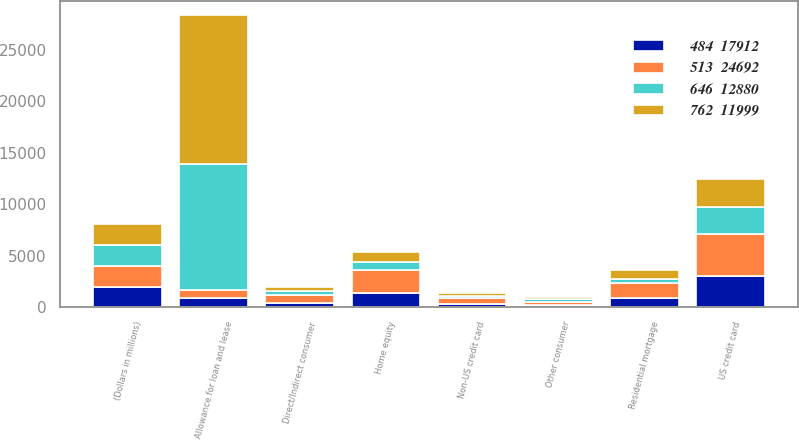<chart> <loc_0><loc_0><loc_500><loc_500><stacked_bar_chart><ecel><fcel>(Dollars in millions)<fcel>Allowance for loan and lease<fcel>Residential mortgage<fcel>Home equity<fcel>US credit card<fcel>Non-US credit card<fcel>Direct/Indirect consumer<fcel>Other consumer<nl><fcel>646  12880<fcel>2016<fcel>12234<fcel>403<fcel>752<fcel>2691<fcel>238<fcel>392<fcel>232<nl><fcel>762  11999<fcel>2015<fcel>14419<fcel>866<fcel>975<fcel>2738<fcel>275<fcel>383<fcel>224<nl><fcel>484  17912<fcel>2014<fcel>860.5<fcel>855<fcel>1364<fcel>3068<fcel>357<fcel>456<fcel>268<nl><fcel>513  24692<fcel>2013<fcel>860.5<fcel>1508<fcel>2258<fcel>4004<fcel>508<fcel>710<fcel>273<nl></chart> 